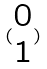<formula> <loc_0><loc_0><loc_500><loc_500>( \begin{matrix} 0 \\ 1 \end{matrix} )</formula> 